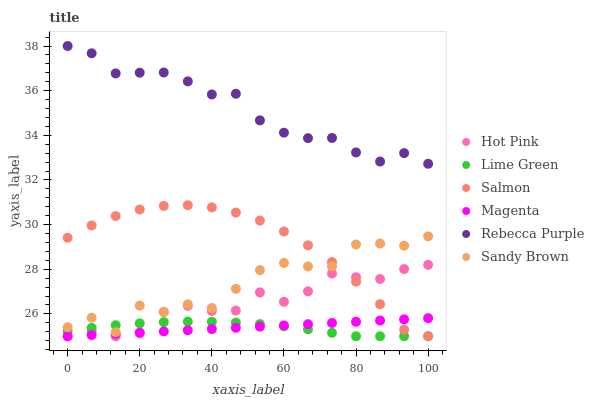Does Lime Green have the minimum area under the curve?
Answer yes or no. Yes. Does Rebecca Purple have the maximum area under the curve?
Answer yes or no. Yes. Does Hot Pink have the minimum area under the curve?
Answer yes or no. No. Does Hot Pink have the maximum area under the curve?
Answer yes or no. No. Is Magenta the smoothest?
Answer yes or no. Yes. Is Sandy Brown the roughest?
Answer yes or no. Yes. Is Hot Pink the smoothest?
Answer yes or no. No. Is Hot Pink the roughest?
Answer yes or no. No. Does Hot Pink have the lowest value?
Answer yes or no. Yes. Does Rebecca Purple have the lowest value?
Answer yes or no. No. Does Rebecca Purple have the highest value?
Answer yes or no. Yes. Does Hot Pink have the highest value?
Answer yes or no. No. Is Lime Green less than Rebecca Purple?
Answer yes or no. Yes. Is Rebecca Purple greater than Salmon?
Answer yes or no. Yes. Does Lime Green intersect Magenta?
Answer yes or no. Yes. Is Lime Green less than Magenta?
Answer yes or no. No. Is Lime Green greater than Magenta?
Answer yes or no. No. Does Lime Green intersect Rebecca Purple?
Answer yes or no. No. 